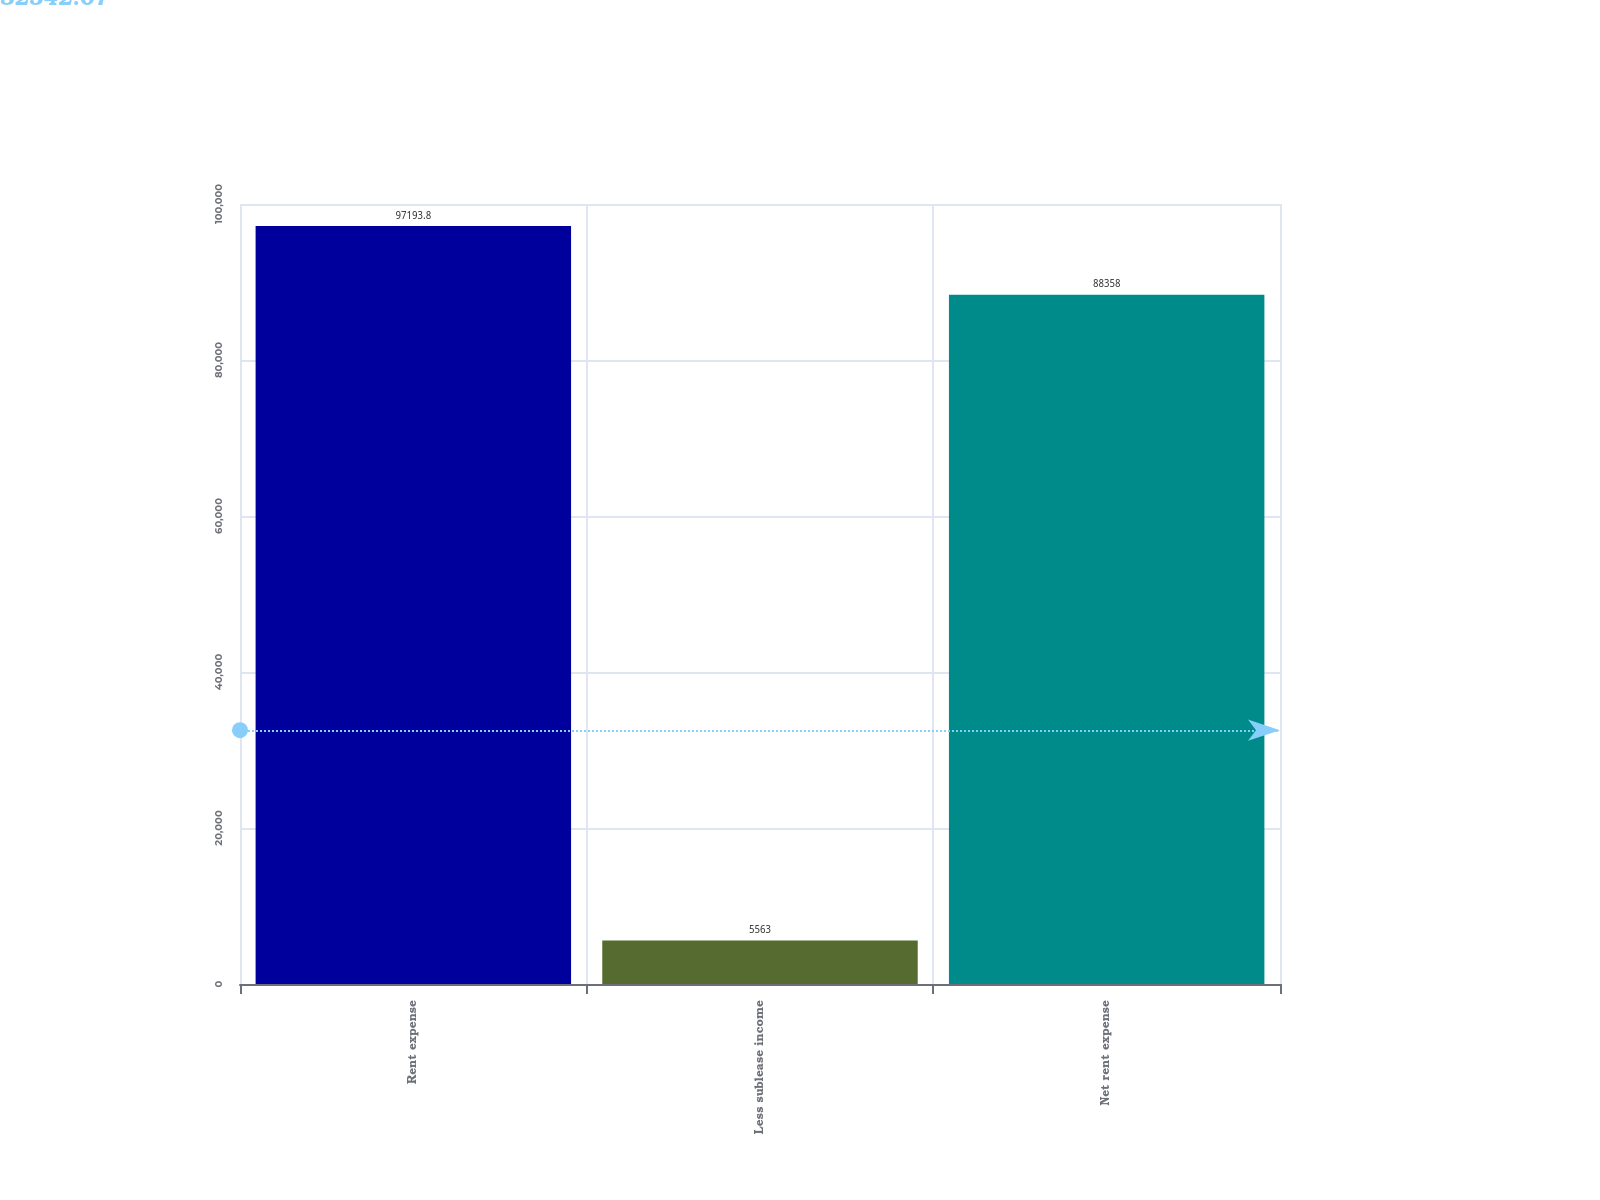Convert chart to OTSL. <chart><loc_0><loc_0><loc_500><loc_500><bar_chart><fcel>Rent expense<fcel>Less sublease income<fcel>Net rent expense<nl><fcel>97193.8<fcel>5563<fcel>88358<nl></chart> 